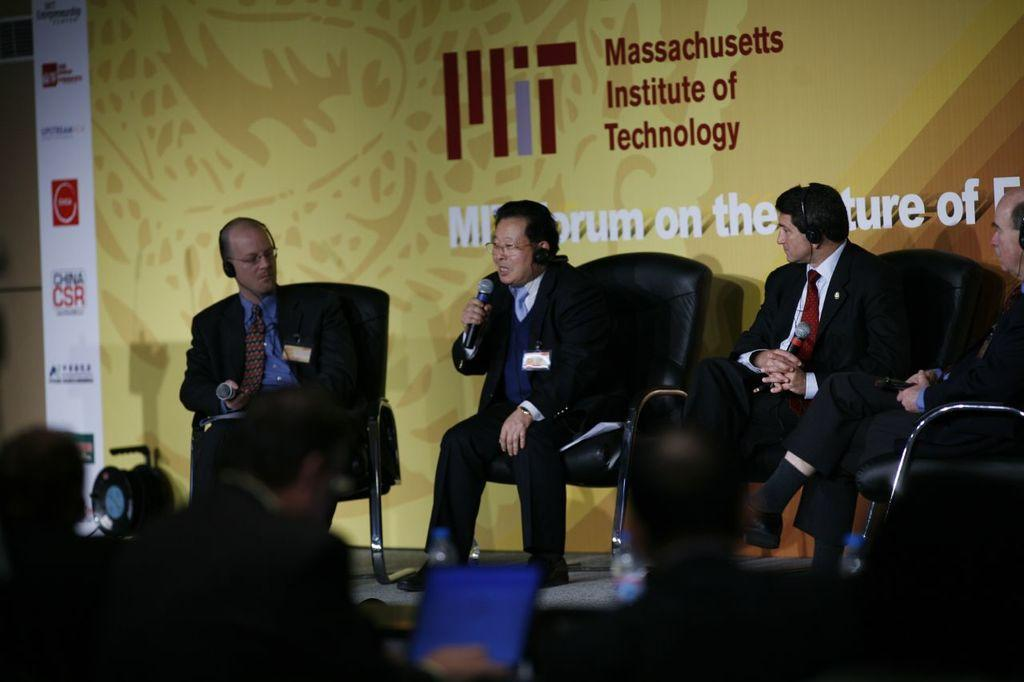How many people are in the image? There is a group of people in the image. What are some of the people doing in the image? Some people are seated on chairs, wearing headsets, and holding microphones. What can be seen in the background of the image? There is a hoarding in the background of the image. What type of jar can be seen in the alley behind the people in the image? There is no jar or alley present in the image. Can you describe the parent of the person holding the microphone in the image? There is no information about the parents of the people in the image, as the focus is on their actions and accessories. 